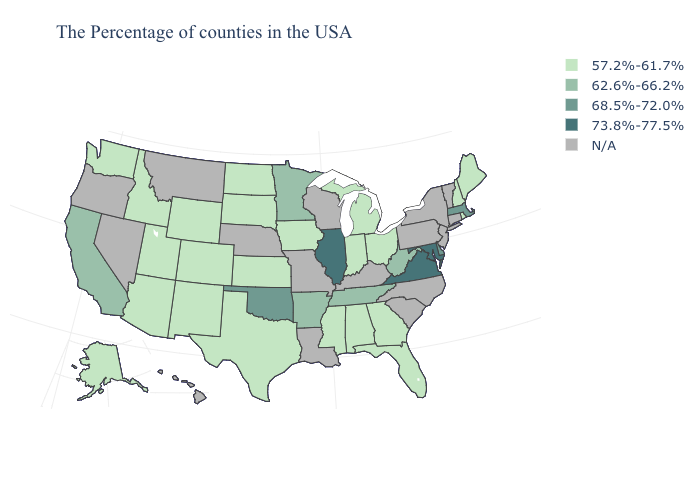What is the value of Virginia?
Answer briefly. 73.8%-77.5%. What is the value of Nevada?
Write a very short answer. N/A. What is the highest value in the Northeast ?
Keep it brief. 68.5%-72.0%. Does Michigan have the lowest value in the USA?
Keep it brief. Yes. Name the states that have a value in the range 73.8%-77.5%?
Answer briefly. Maryland, Virginia, Illinois. What is the lowest value in the MidWest?
Short answer required. 57.2%-61.7%. What is the lowest value in the USA?
Short answer required. 57.2%-61.7%. Does Alaska have the highest value in the West?
Write a very short answer. No. Is the legend a continuous bar?
Answer briefly. No. Name the states that have a value in the range 62.6%-66.2%?
Concise answer only. West Virginia, Tennessee, Arkansas, Minnesota, California. Is the legend a continuous bar?
Concise answer only. No. Which states have the highest value in the USA?
Short answer required. Maryland, Virginia, Illinois. What is the value of Indiana?
Write a very short answer. 57.2%-61.7%. 